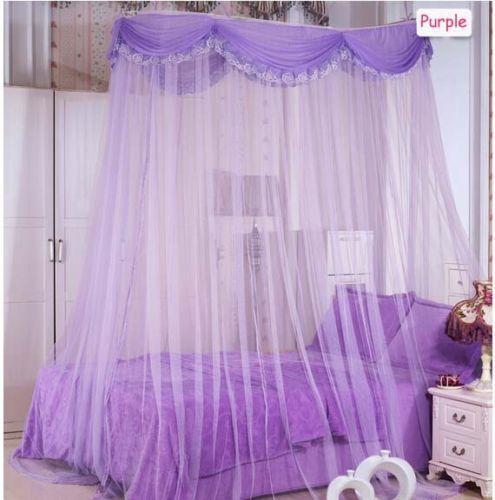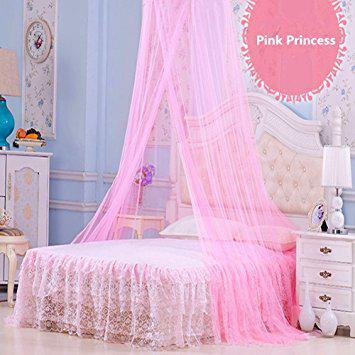The first image is the image on the left, the second image is the image on the right. Evaluate the accuracy of this statement regarding the images: "The image on the left contains a pink circular net over a bed.". Is it true? Answer yes or no. No. The first image is the image on the left, the second image is the image on the right. Evaluate the accuracy of this statement regarding the images: "One of the beds has four posts.". Is it true? Answer yes or no. No. 